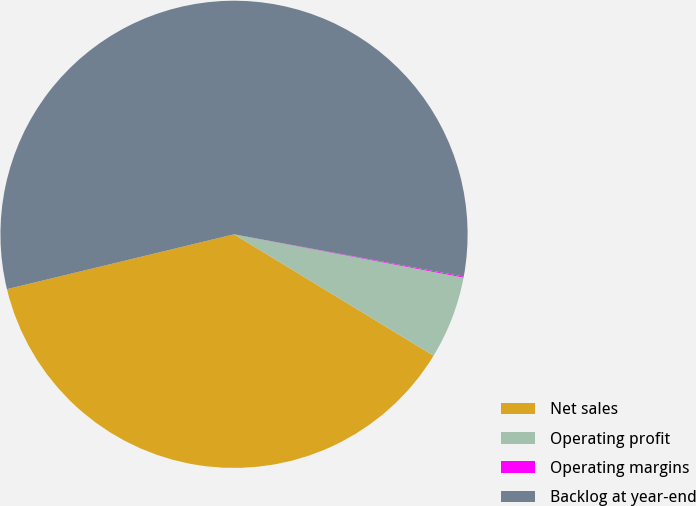<chart> <loc_0><loc_0><loc_500><loc_500><pie_chart><fcel>Net sales<fcel>Operating profit<fcel>Operating margins<fcel>Backlog at year-end<nl><fcel>37.53%<fcel>5.73%<fcel>0.07%<fcel>56.67%<nl></chart> 